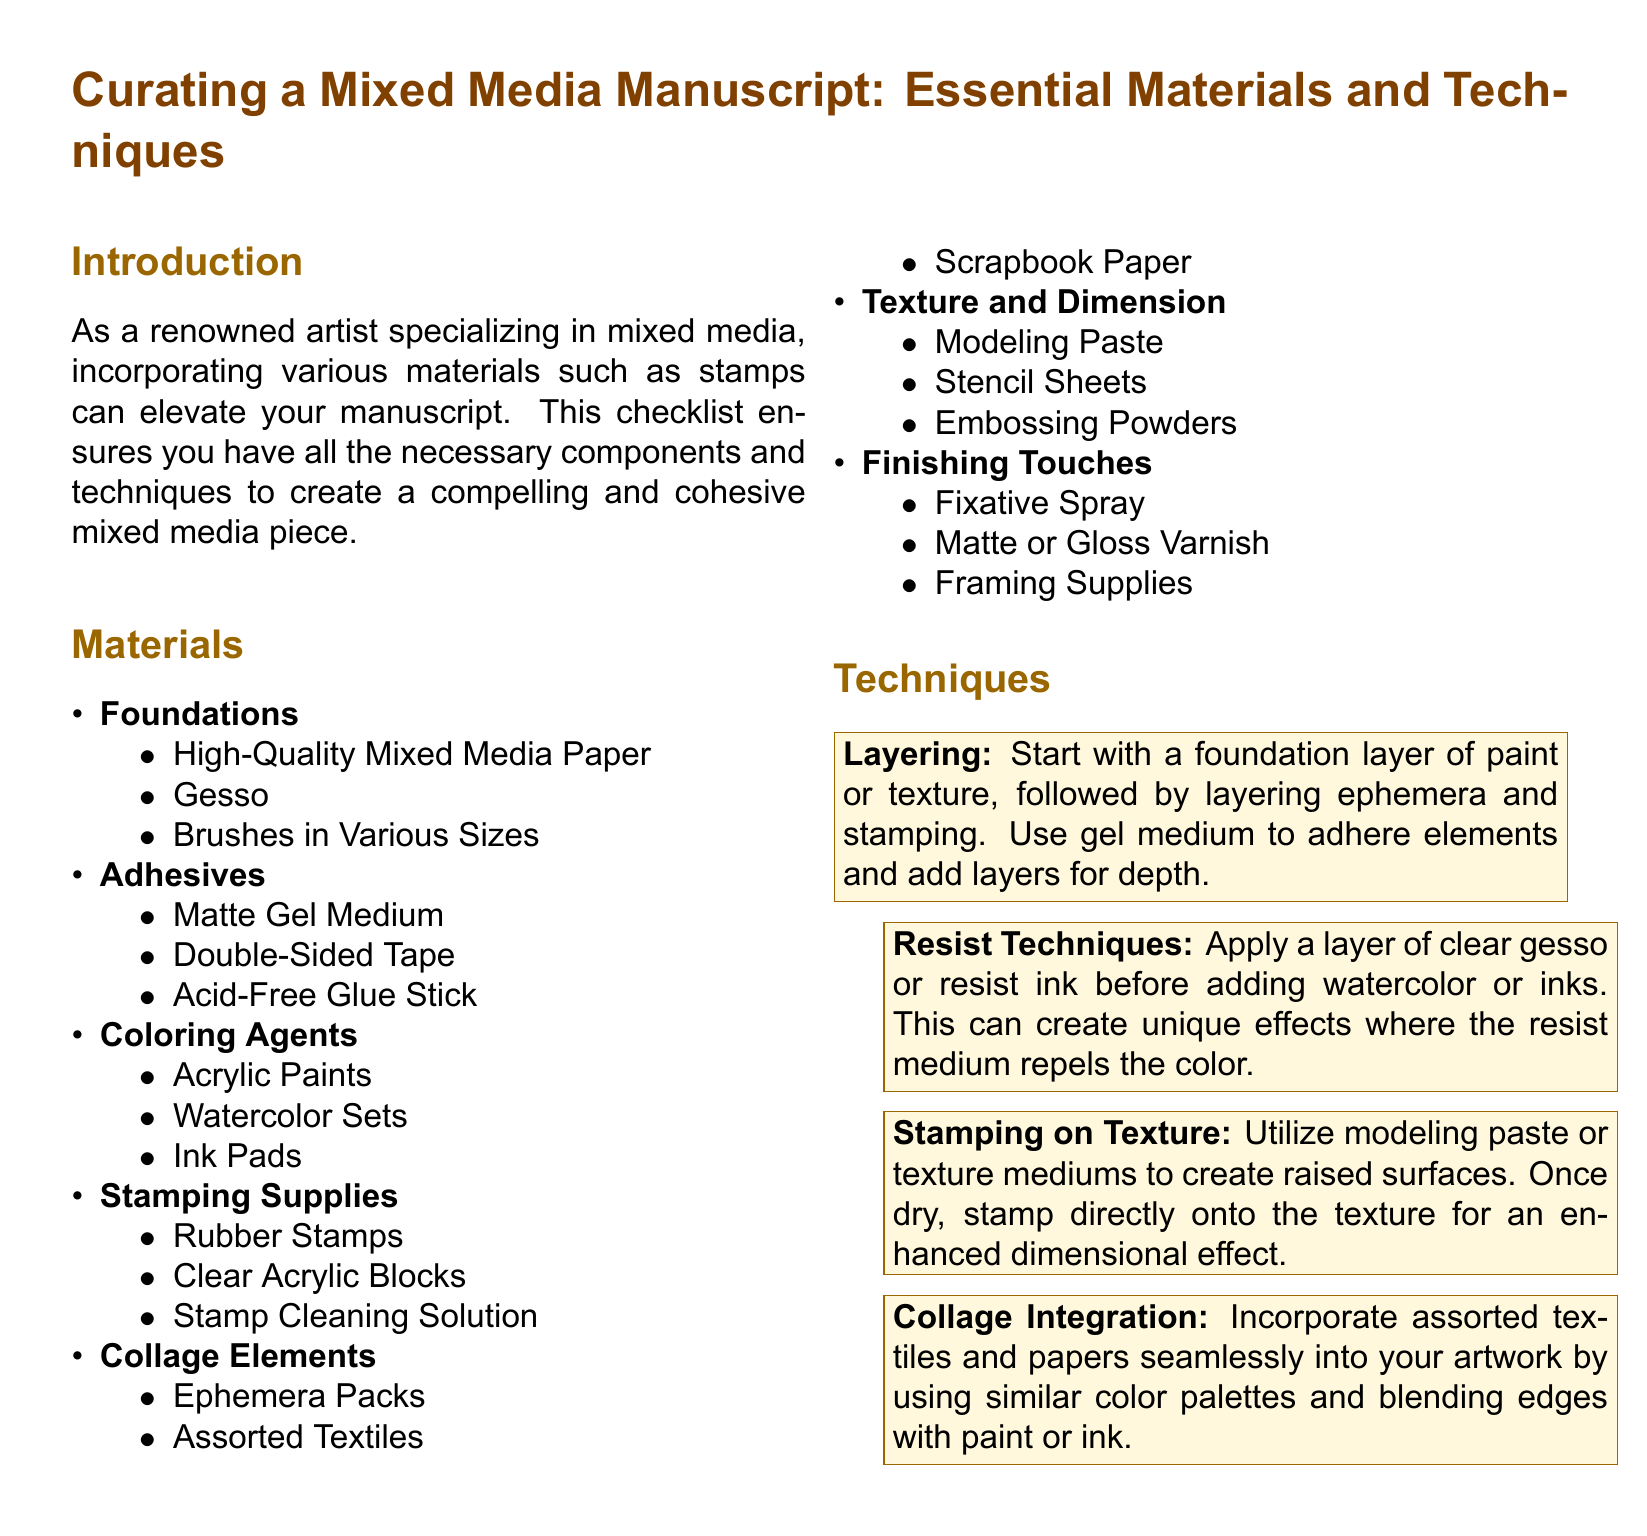What is the first item listed under Foundations? The first item listed under Foundations is High-Quality Mixed Media Paper.
Answer: High-Quality Mixed Media Paper How many different types of Adhesives are mentioned? The document lists three types of Adhesives under the respective section.
Answer: 3 What is one material required for stamping? The document specifies Rubber Stamps as one of the materials under Stamping Supplies.
Answer: Rubber Stamps Which technique involves using clear gesso or resist ink? The technique described that involves using clear gesso or resist ink is Resist Techniques.
Answer: Resist Techniques What is used to create raised surfaces before stamping? The document indicates Modeling Paste as the material to create raised surfaces before stamping.
Answer: Modeling Paste How are textiles and papers incorporated into artwork? The document suggests using similar color palettes and blending edges with paint or ink for integration.
Answer: Similar color palettes and blending edges What is the purpose of the Fixative Spray mentioned? The Fixative Spray is classified as a Finishing Touch to protect the artwork.
Answer: Protect the artwork What section of the document includes Acrylic Paints? Acrylic Paints are listed under the Coloring Agents section.
Answer: Coloring Agents Which technique enhances dimensional effect when stamping? The technique that enhances the dimensional effect when stamping is Stamping on Texture.
Answer: Stamping on Texture 